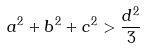Convert formula to latex. <formula><loc_0><loc_0><loc_500><loc_500>a ^ { 2 } + b ^ { 2 } + c ^ { 2 } > \frac { d ^ { 2 } } { 3 }</formula> 